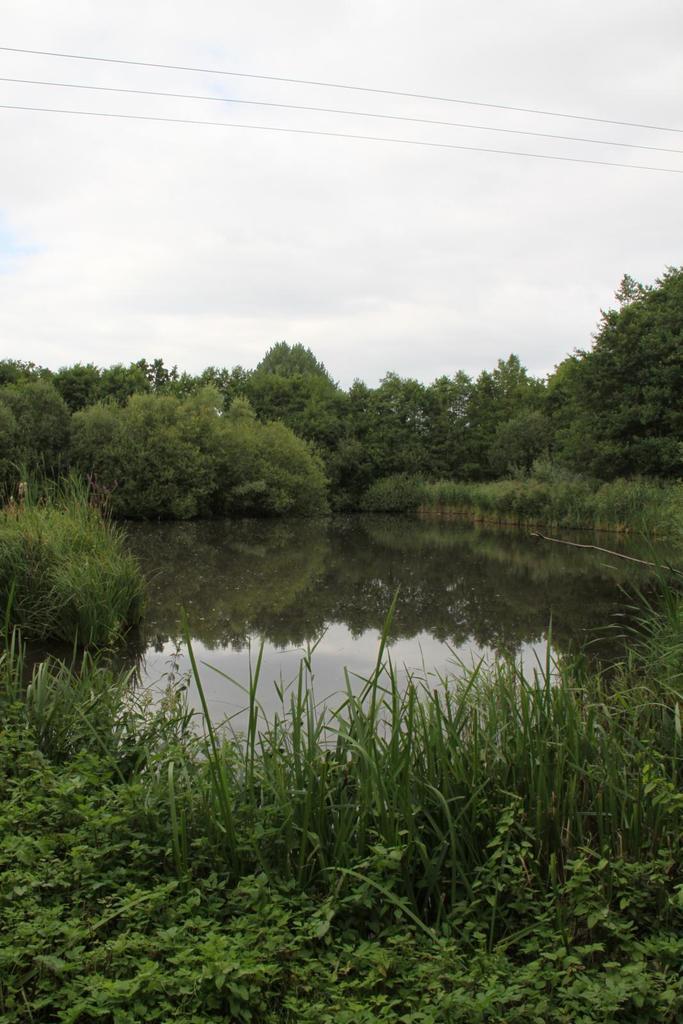In one or two sentences, can you explain what this image depicts? In this image, we can see so many tree, planted, grass, water. Top of the image, there is a sky. 